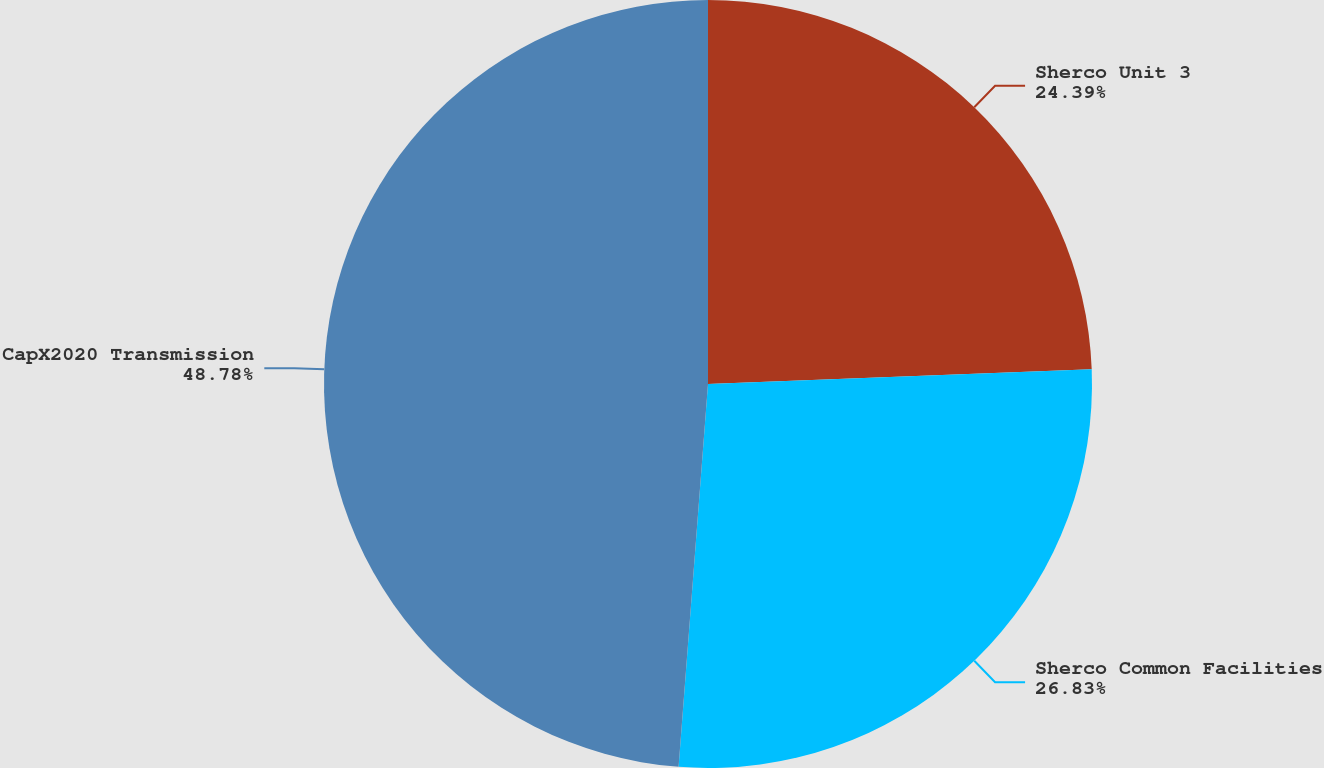<chart> <loc_0><loc_0><loc_500><loc_500><pie_chart><fcel>Sherco Unit 3<fcel>Sherco Common Facilities<fcel>CapX2020 Transmission<nl><fcel>24.39%<fcel>26.83%<fcel>48.78%<nl></chart> 